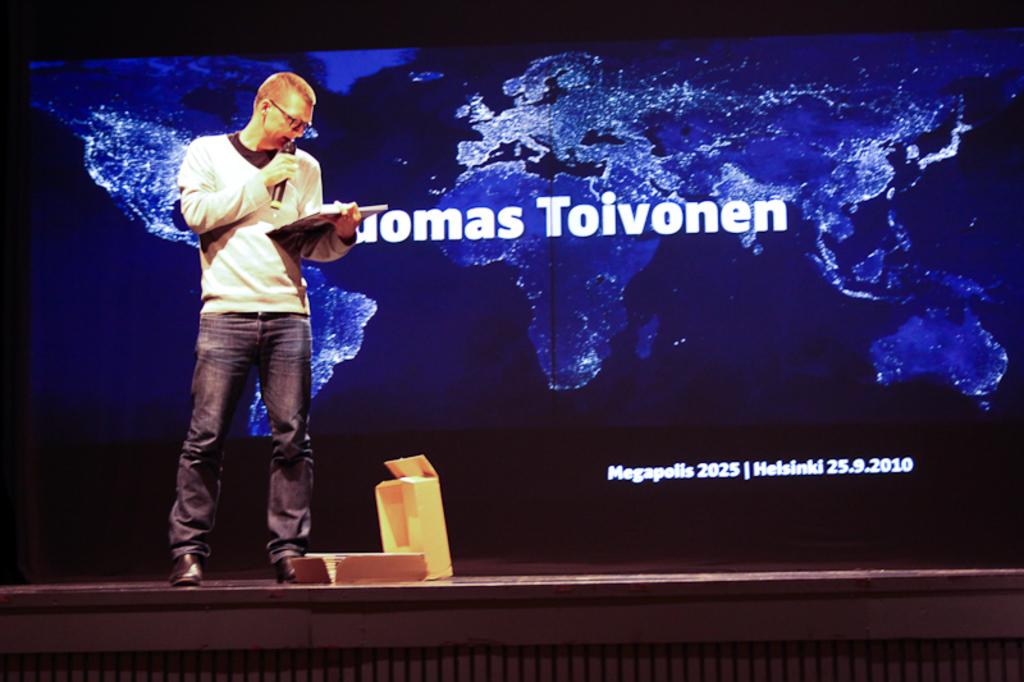What is the date of this event?
Your response must be concise. 25.9.2010. 